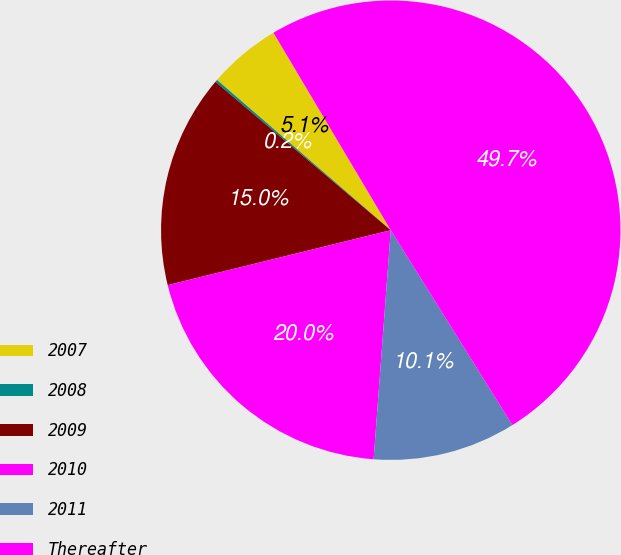Convert chart to OTSL. <chart><loc_0><loc_0><loc_500><loc_500><pie_chart><fcel>2007<fcel>2008<fcel>2009<fcel>2010<fcel>2011<fcel>Thereafter<nl><fcel>5.12%<fcel>0.17%<fcel>15.02%<fcel>19.97%<fcel>10.07%<fcel>49.65%<nl></chart> 